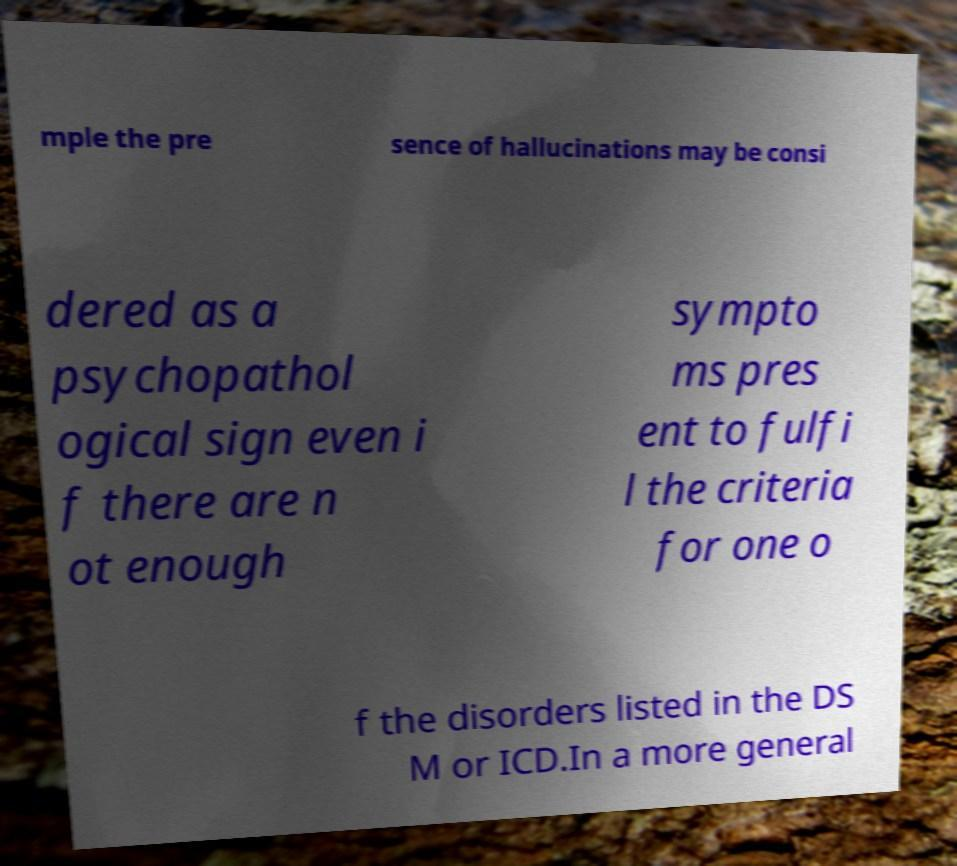Please read and relay the text visible in this image. What does it say? mple the pre sence of hallucinations may be consi dered as a psychopathol ogical sign even i f there are n ot enough sympto ms pres ent to fulfi l the criteria for one o f the disorders listed in the DS M or ICD.In a more general 